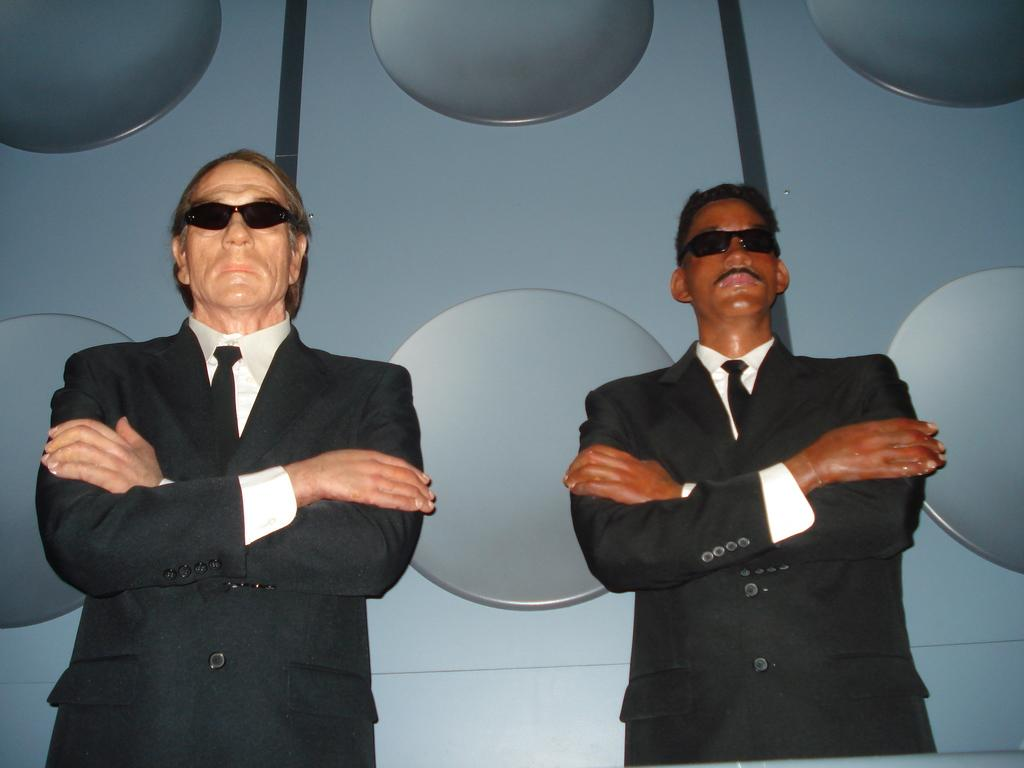What is depicted in the image? There are statues of two men in the image. What are the positions of the men in the statues? The men are standing. What are the men wearing in the statues? The men are wearing formal suits and black color sunglasses. What is visible behind the statues? There is a wall behind the statues. What type of shade do the frogs provide in the image? There are no frogs present in the image, so they cannot provide any shade. 